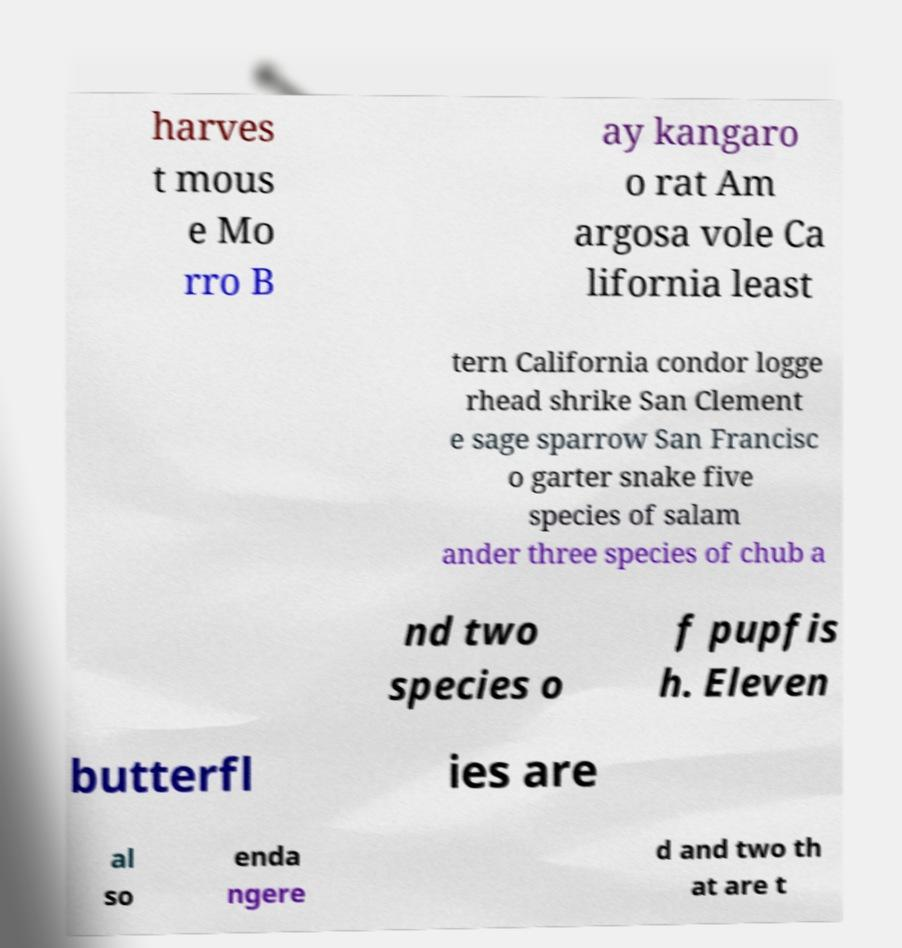For documentation purposes, I need the text within this image transcribed. Could you provide that? harves t mous e Mo rro B ay kangaro o rat Am argosa vole Ca lifornia least tern California condor logge rhead shrike San Clement e sage sparrow San Francisc o garter snake five species of salam ander three species of chub a nd two species o f pupfis h. Eleven butterfl ies are al so enda ngere d and two th at are t 